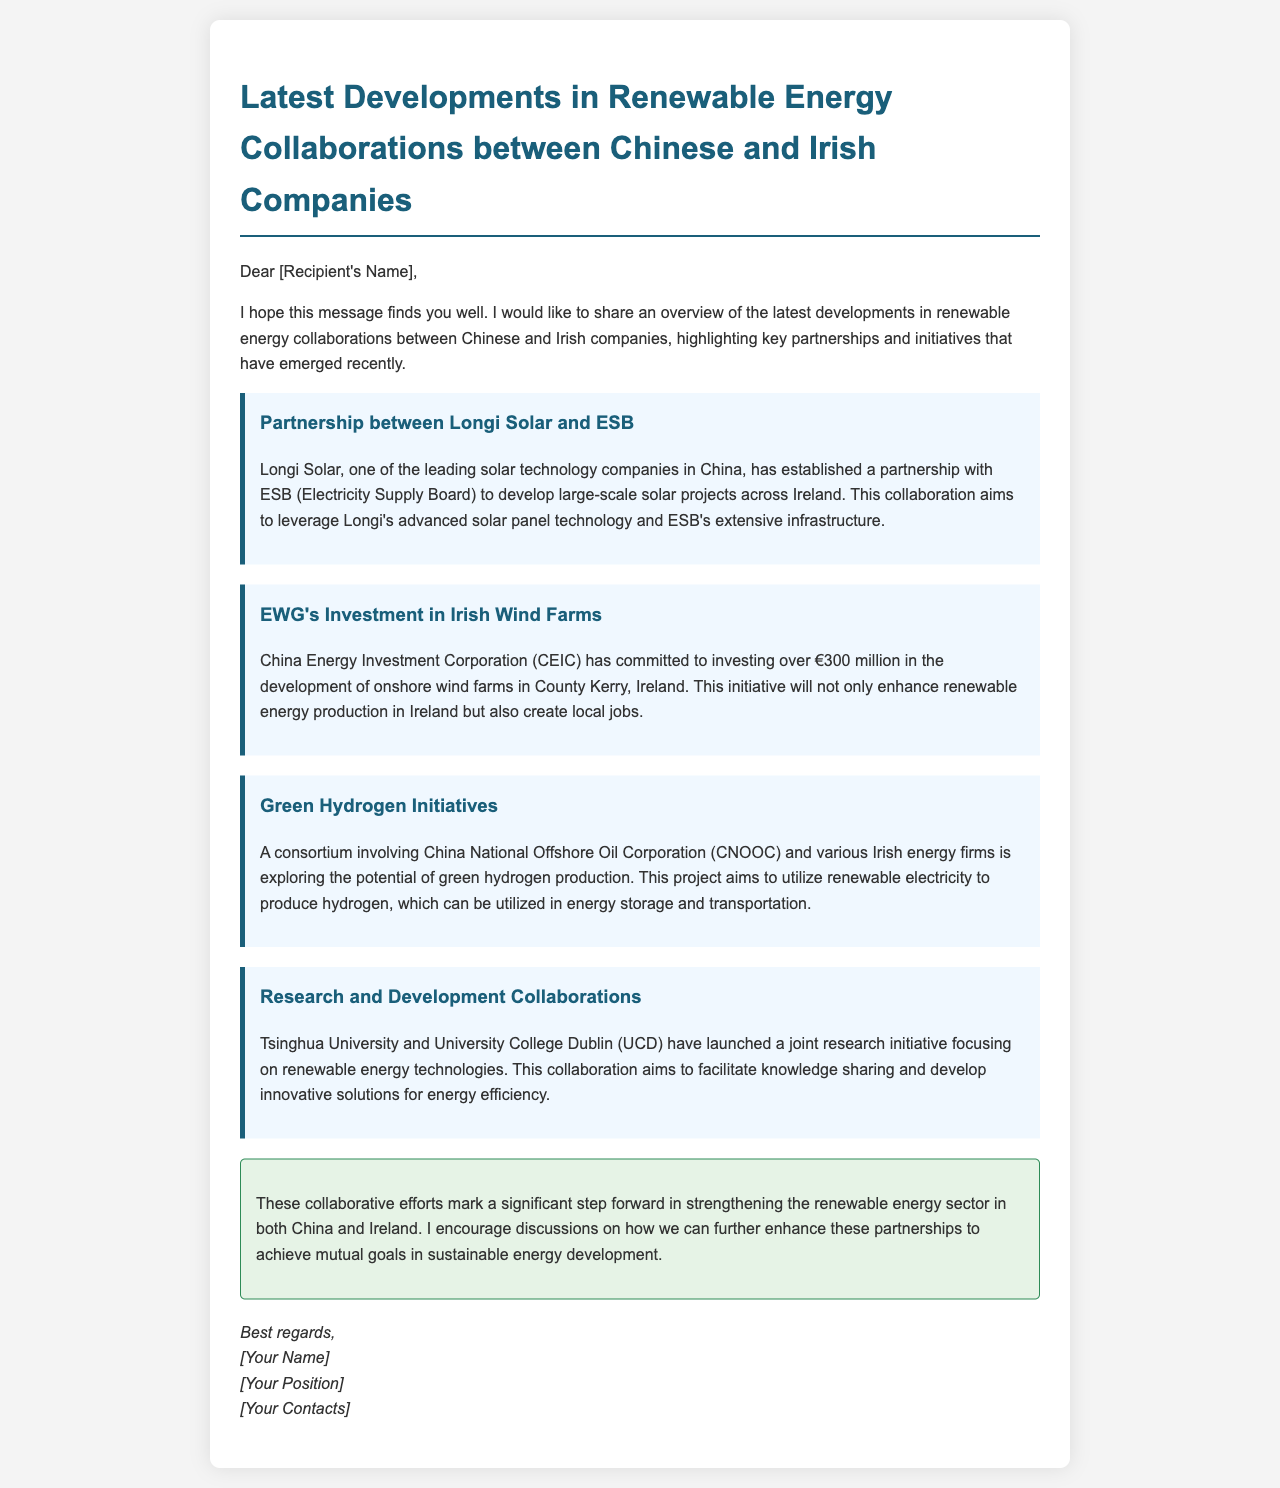What is the name of the Chinese company partnered with ESB? The document states that Longi Solar is the partnered Chinese company with ESB.
Answer: Longi Solar How much is CEIC investing in Irish wind farms? The document mentions that CEIC is committing to invest over €300 million in the development of onshore wind farms.
Answer: €300 million What type of technology is Tsinghua University and UCD focusing on? The document indicates that their joint research initiative focuses on renewable energy technologies.
Answer: Renewable energy technologies Which Irish county is highlighted for wind farm developments by CEIC? The document specifies County Kerry as the location for the wind farm developments.
Answer: County Kerry What energy production method does the green hydrogen project utilize? The document states that the project aims to utilize renewable electricity to produce hydrogen.
Answer: Renewable electricity What is the key aim of the partnership between Longi Solar and ESB? The document notes that the aim is to develop large-scale solar projects across Ireland.
Answer: Develop large-scale solar projects What is the main goal of the consortium involving CNOOC and Irish firms? The document indicates that the goal is to explore the potential of green hydrogen production.
Answer: Explore green hydrogen production What is the overall purpose of the collaborative efforts discussed? The document concludes that these efforts mark a significant step in strengthening the renewable energy sector.
Answer: Strengthening the renewable energy sector 